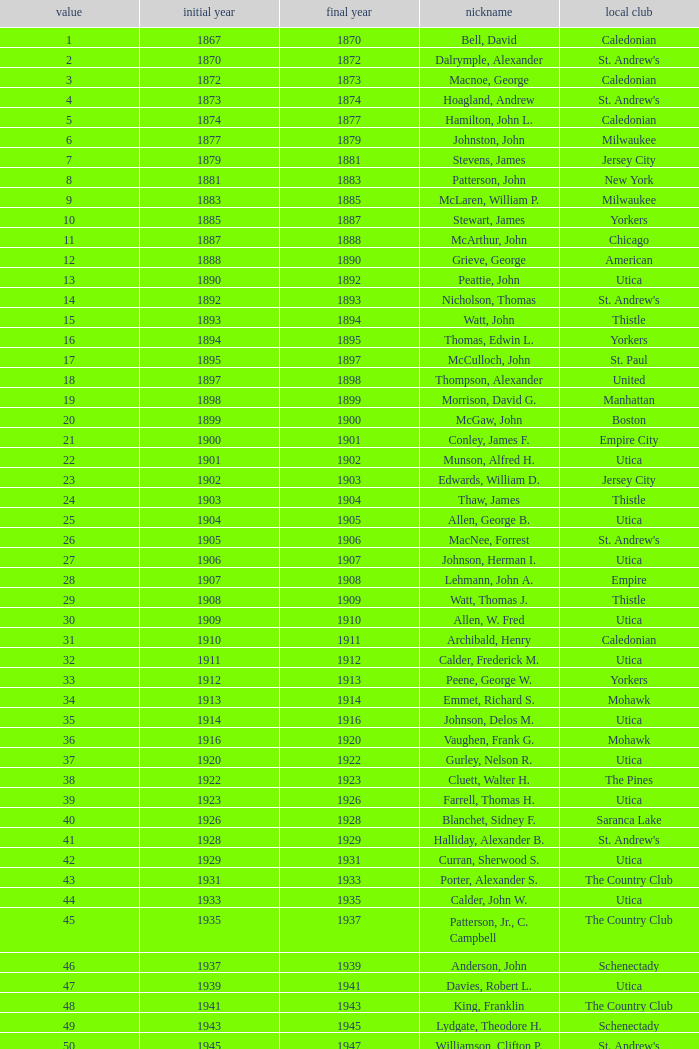Which Year Start has a Number of 28? 1907.0. 